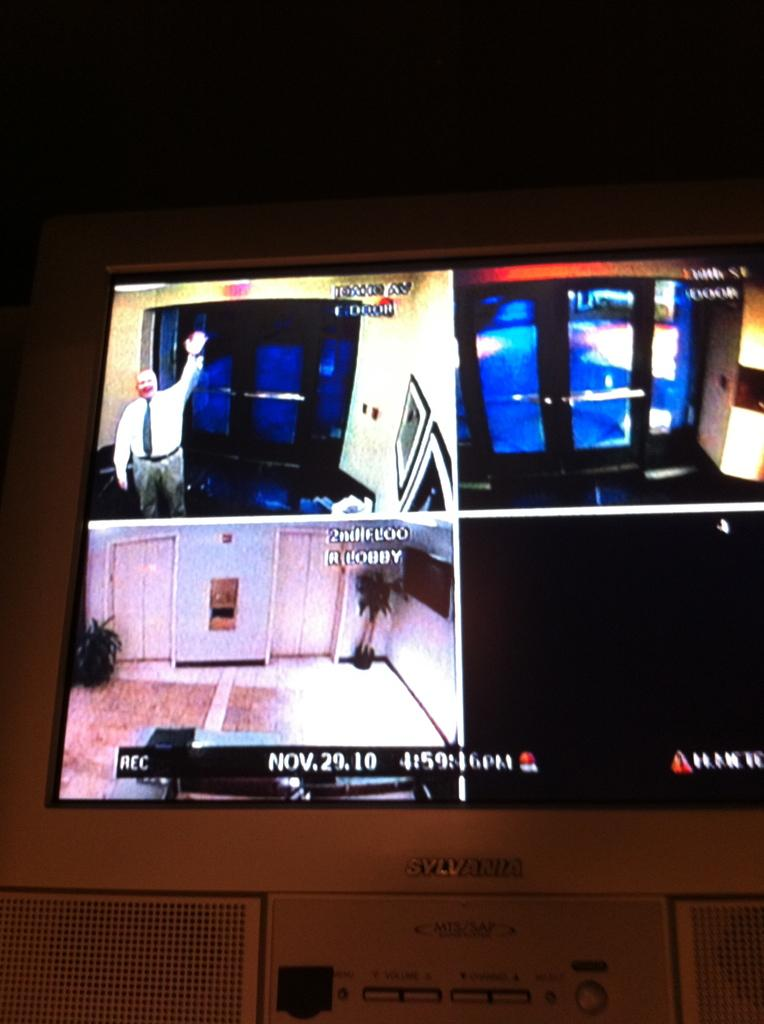Provide a one-sentence caption for the provided image. the date is November 29th and there are plenty of screens. 